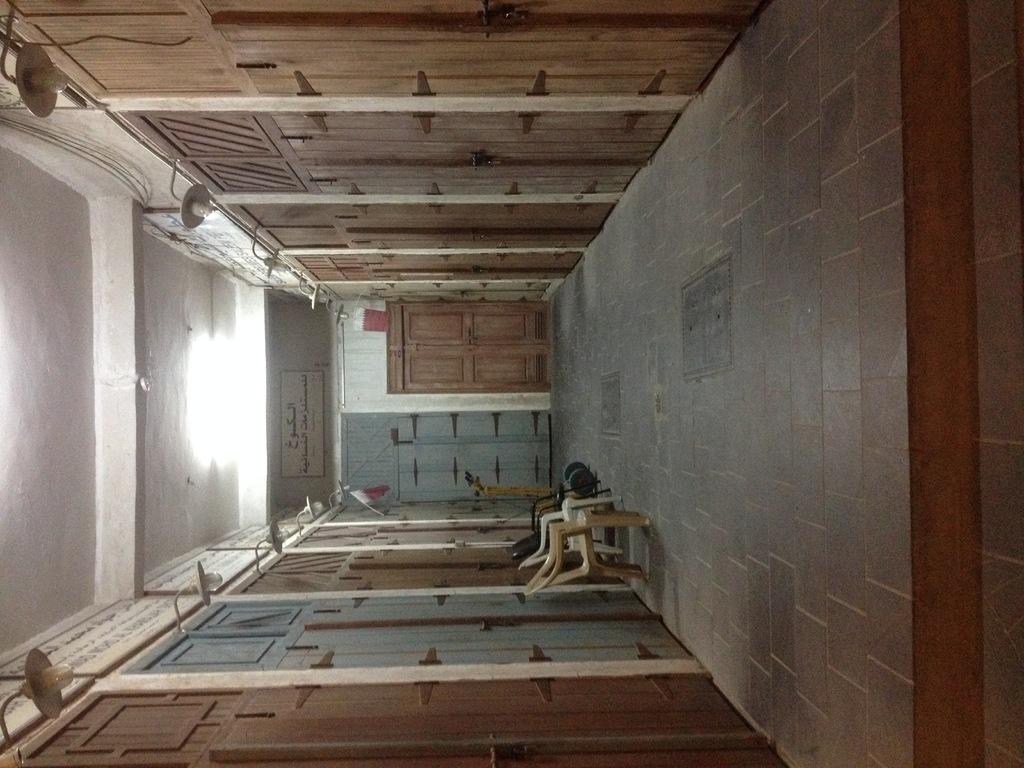What type of structure can be seen in the image? There is a wall in the image. What can be found on the wall in the image? There are lights and doors in the image. Are there any other objects attached to the wall in the image? Yes, there are other objects attached to the wall in the image. How does the team use friction to overcome their fear in the image? There is no team, friction, or fear present in the image. 